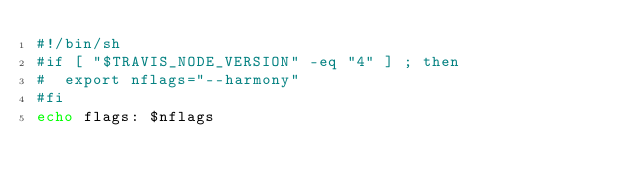Convert code to text. <code><loc_0><loc_0><loc_500><loc_500><_Bash_>#!/bin/sh
#if [ "$TRAVIS_NODE_VERSION" -eq "4" ] ; then
#  export nflags="--harmony"
#fi
echo flags: $nflags
</code> 